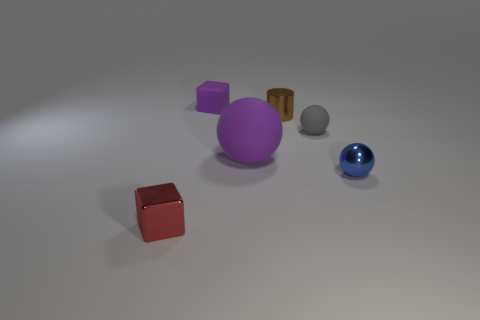Add 2 purple spheres. How many objects exist? 8 Subtract all small balls. How many balls are left? 1 Subtract all purple spheres. How many spheres are left? 2 Subtract 2 spheres. How many spheres are left? 1 Subtract all red cubes. How many cyan balls are left? 0 Subtract all large green metallic cubes. Subtract all tiny blue shiny balls. How many objects are left? 5 Add 4 gray balls. How many gray balls are left? 5 Add 4 small red things. How many small red things exist? 5 Subtract 0 purple cylinders. How many objects are left? 6 Subtract all cylinders. How many objects are left? 5 